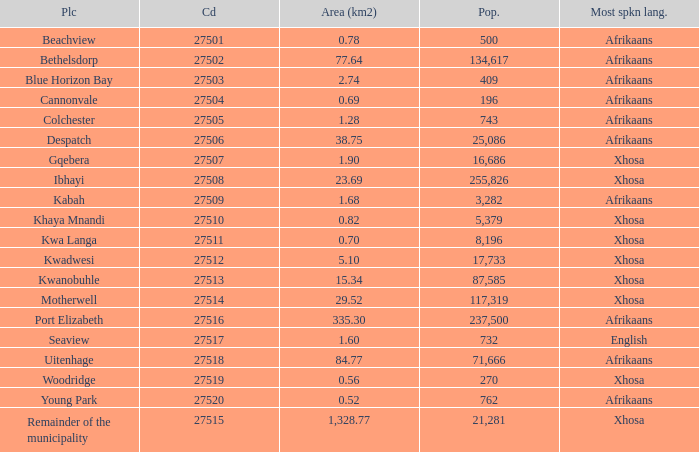What is the total code number for places with a population greater than 87,585? 4.0. 